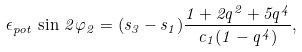Convert formula to latex. <formula><loc_0><loc_0><loc_500><loc_500>\epsilon _ { p o t } \, \sin \, 2 \varphi _ { 2 } = ( s _ { 3 } - s _ { 1 } ) \frac { 1 + 2 q ^ { 2 } + 5 q ^ { 4 } } { c _ { 1 } ( 1 - q ^ { 4 } ) } ,</formula> 